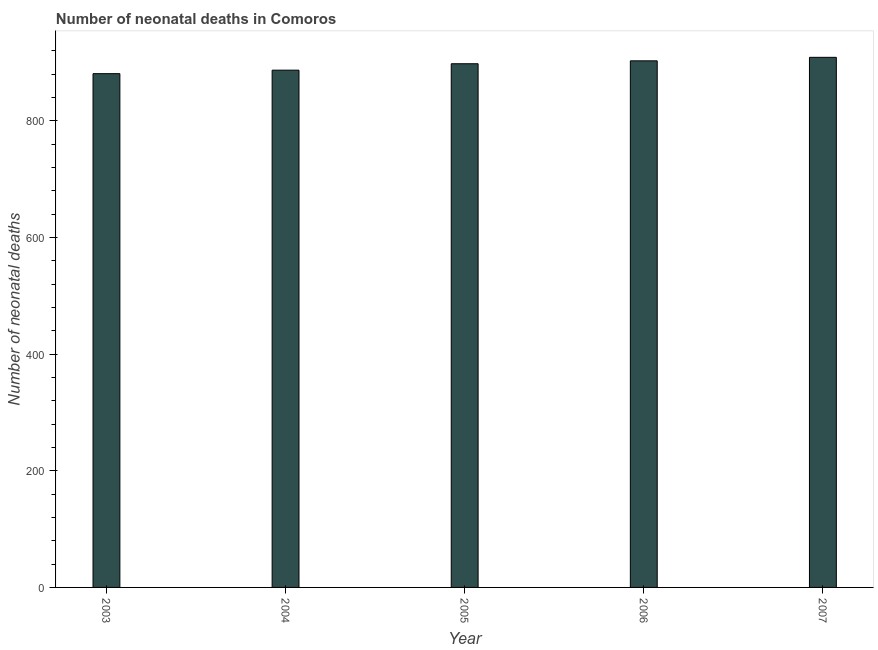Does the graph contain any zero values?
Make the answer very short. No. What is the title of the graph?
Offer a very short reply. Number of neonatal deaths in Comoros. What is the label or title of the Y-axis?
Offer a very short reply. Number of neonatal deaths. What is the number of neonatal deaths in 2004?
Ensure brevity in your answer.  887. Across all years, what is the maximum number of neonatal deaths?
Make the answer very short. 909. Across all years, what is the minimum number of neonatal deaths?
Keep it short and to the point. 881. What is the sum of the number of neonatal deaths?
Your answer should be very brief. 4478. What is the difference between the number of neonatal deaths in 2006 and 2007?
Provide a succinct answer. -6. What is the average number of neonatal deaths per year?
Ensure brevity in your answer.  895. What is the median number of neonatal deaths?
Keep it short and to the point. 898. Is the number of neonatal deaths in 2005 less than that in 2006?
Offer a terse response. Yes. Is the difference between the number of neonatal deaths in 2005 and 2006 greater than the difference between any two years?
Provide a short and direct response. No. What is the difference between the highest and the second highest number of neonatal deaths?
Give a very brief answer. 6. Is the sum of the number of neonatal deaths in 2005 and 2007 greater than the maximum number of neonatal deaths across all years?
Ensure brevity in your answer.  Yes. What is the difference between the highest and the lowest number of neonatal deaths?
Give a very brief answer. 28. In how many years, is the number of neonatal deaths greater than the average number of neonatal deaths taken over all years?
Provide a short and direct response. 3. How many bars are there?
Give a very brief answer. 5. How many years are there in the graph?
Keep it short and to the point. 5. What is the Number of neonatal deaths of 2003?
Keep it short and to the point. 881. What is the Number of neonatal deaths in 2004?
Keep it short and to the point. 887. What is the Number of neonatal deaths in 2005?
Your answer should be very brief. 898. What is the Number of neonatal deaths in 2006?
Keep it short and to the point. 903. What is the Number of neonatal deaths in 2007?
Give a very brief answer. 909. What is the difference between the Number of neonatal deaths in 2004 and 2006?
Make the answer very short. -16. What is the difference between the Number of neonatal deaths in 2005 and 2006?
Provide a succinct answer. -5. What is the difference between the Number of neonatal deaths in 2005 and 2007?
Make the answer very short. -11. What is the difference between the Number of neonatal deaths in 2006 and 2007?
Ensure brevity in your answer.  -6. What is the ratio of the Number of neonatal deaths in 2004 to that in 2007?
Ensure brevity in your answer.  0.98. What is the ratio of the Number of neonatal deaths in 2005 to that in 2006?
Provide a succinct answer. 0.99. What is the ratio of the Number of neonatal deaths in 2005 to that in 2007?
Give a very brief answer. 0.99. 